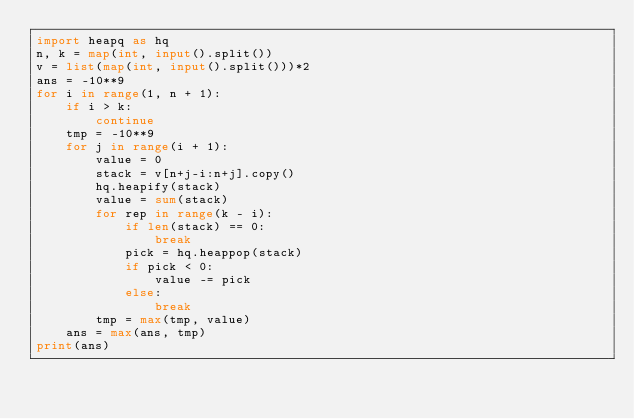Convert code to text. <code><loc_0><loc_0><loc_500><loc_500><_Python_>import heapq as hq
n, k = map(int, input().split())
v = list(map(int, input().split()))*2
ans = -10**9
for i in range(1, n + 1):
    if i > k:
        continue
    tmp = -10**9
    for j in range(i + 1):
        value = 0
        stack = v[n+j-i:n+j].copy()
        hq.heapify(stack)
        value = sum(stack)
        for rep in range(k - i):
            if len(stack) == 0:
                break
            pick = hq.heappop(stack)
            if pick < 0:
                value -= pick
            else:
                break
        tmp = max(tmp, value)
    ans = max(ans, tmp)
print(ans)</code> 